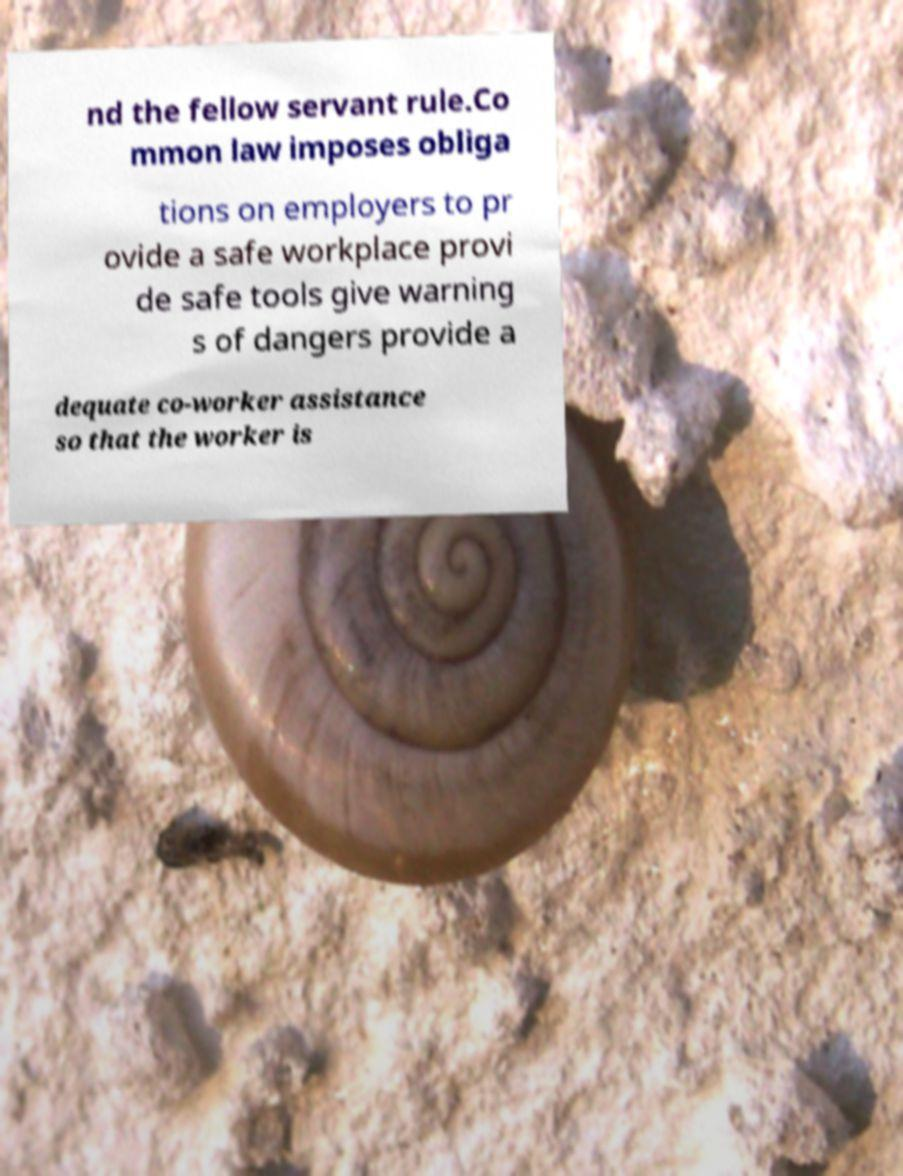Please read and relay the text visible in this image. What does it say? nd the fellow servant rule.Co mmon law imposes obliga tions on employers to pr ovide a safe workplace provi de safe tools give warning s of dangers provide a dequate co-worker assistance so that the worker is 